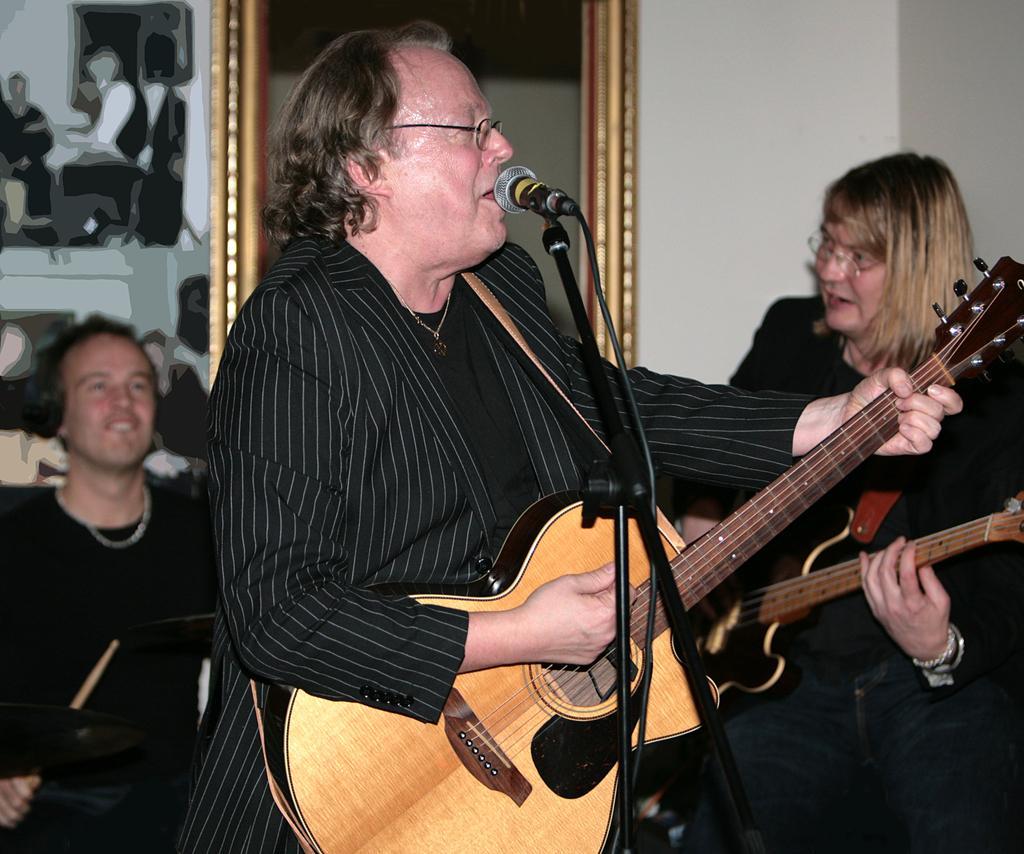Describe this image in one or two sentences. A man is playing guitar while singing with mic in front of him. There is another man playing guitar beside him. There is man playing drums in the background. 